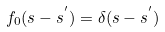Convert formula to latex. <formula><loc_0><loc_0><loc_500><loc_500>f _ { 0 } ( s - s ^ { ^ { \prime } } ) = \delta ( s - s ^ { ^ { \prime } } )</formula> 